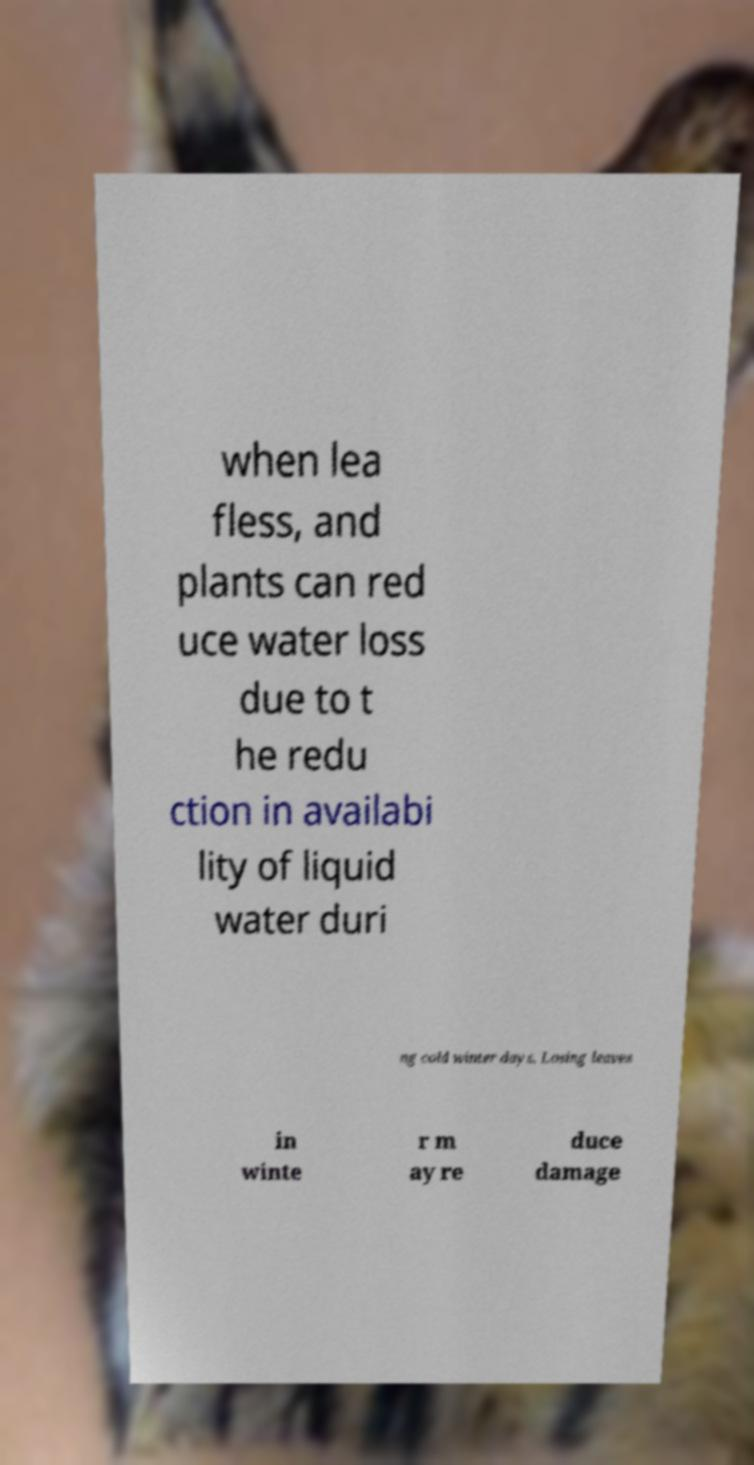Please read and relay the text visible in this image. What does it say? when lea fless, and plants can red uce water loss due to t he redu ction in availabi lity of liquid water duri ng cold winter days. Losing leaves in winte r m ay re duce damage 